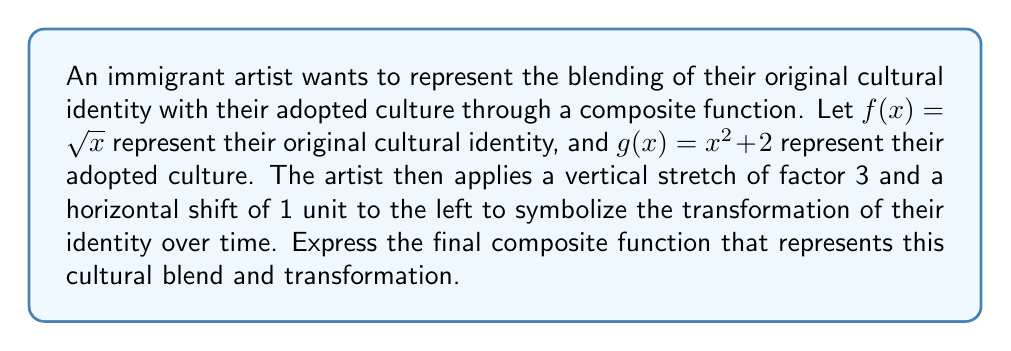Could you help me with this problem? Let's approach this step-by-step:

1) First, we need to create the composite function $(g \circ f)(x)$:
   $$(g \circ f)(x) = g(f(x)) = (\sqrt{x})^2 + 2 = x + 2$$

2) Now, we apply the transformations:
   - Vertical stretch by a factor of 3: $3(x + 2)$
   - Horizontal shift 1 unit left: Replace $x$ with $(x + 1)$

3) Applying these transformations to our composite function:
   $$h(x) = 3((x + 1) + 2)$$

4) Simplify:
   $$h(x) = 3(x + 3)$$
   $$h(x) = 3x + 9$$

Therefore, the final function representing the blended and transformed cultural identity is $h(x) = 3x + 9$.
Answer: $h(x) = 3x + 9$ 